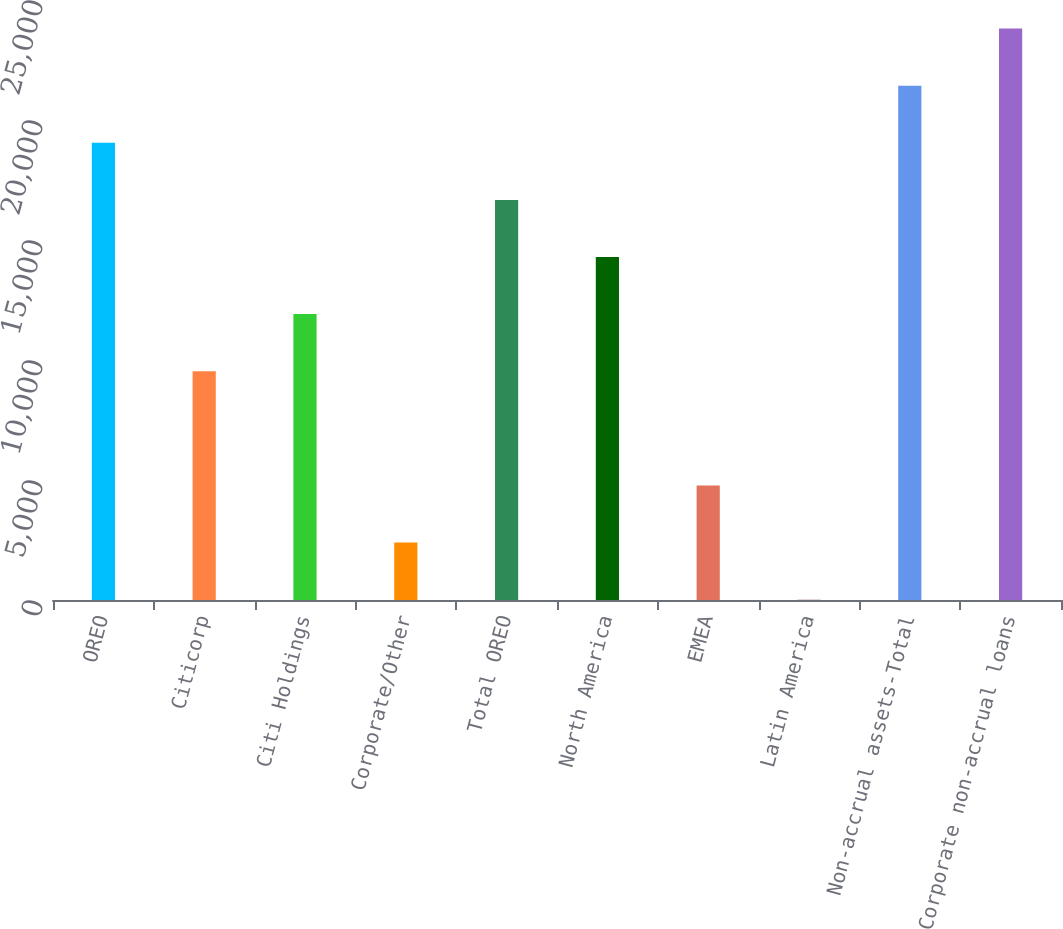<chart> <loc_0><loc_0><loc_500><loc_500><bar_chart><fcel>OREO<fcel>Citicorp<fcel>Citi Holdings<fcel>Corporate/Other<fcel>Total OREO<fcel>North America<fcel>EMEA<fcel>Latin America<fcel>Non-accrual assets-Total<fcel>Corporate non-accrual loans<nl><fcel>19049.6<fcel>9532.8<fcel>11912<fcel>2395.2<fcel>16670.4<fcel>14291.2<fcel>4774.4<fcel>16<fcel>21428.8<fcel>23808<nl></chart> 